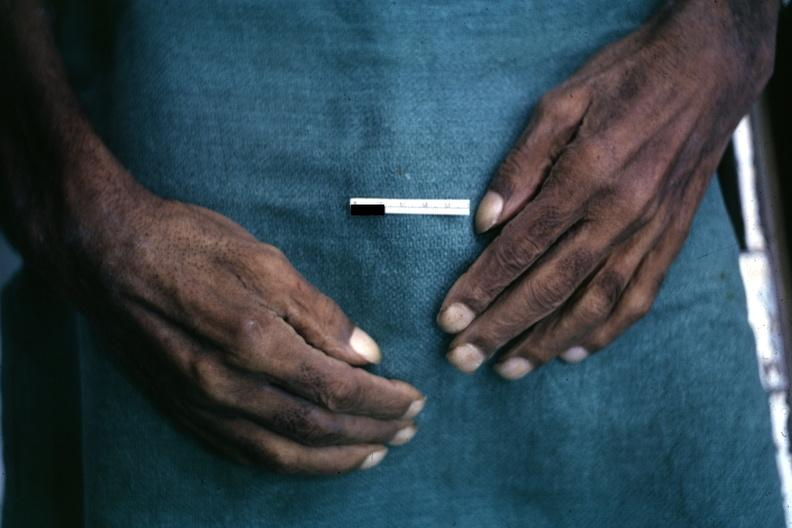s pulmonary osteoarthropathy present?
Answer the question using a single word or phrase. Yes 